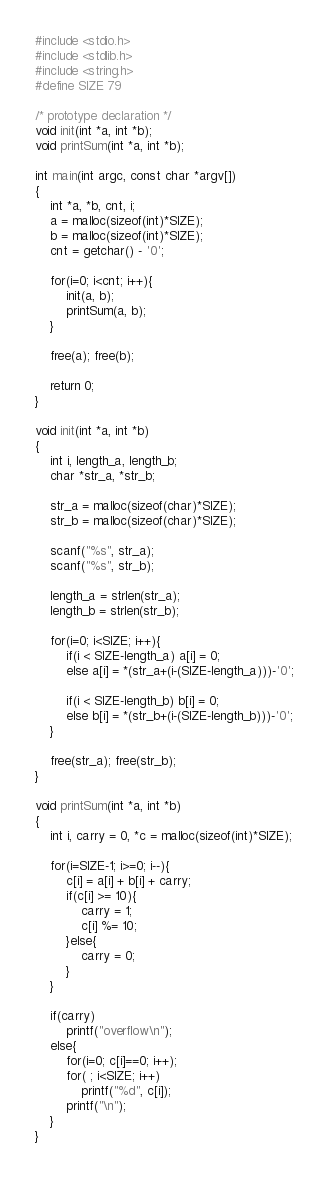<code> <loc_0><loc_0><loc_500><loc_500><_C_>#include <stdio.h>
#include <stdlib.h>
#include <string.h>
#define SIZE 79 

/* prototype declaration */
void init(int *a, int *b);
void printSum(int *a, int *b);

int main(int argc, const char *argv[])
{
	int *a, *b, cnt, i;
	a = malloc(sizeof(int)*SIZE);
	b = malloc(sizeof(int)*SIZE);
	cnt = getchar() - '0';

	for(i=0; i<cnt; i++){
		init(a, b);
		printSum(a, b);
	}
	
	free(a); free(b);

	return 0;
}

void init(int *a, int *b)
{
	int i, length_a, length_b;
	char *str_a, *str_b;

	str_a = malloc(sizeof(char)*SIZE);
	str_b = malloc(sizeof(char)*SIZE);

	scanf("%s", str_a);
	scanf("%s", str_b);

	length_a = strlen(str_a);
	length_b = strlen(str_b);

	for(i=0; i<SIZE; i++){
		if(i < SIZE-length_a) a[i] = 0;
		else a[i] = *(str_a+(i-(SIZE-length_a)))-'0';
		
		if(i < SIZE-length_b) b[i] = 0;
		else b[i] = *(str_b+(i-(SIZE-length_b)))-'0';
	}

	free(str_a); free(str_b);
}

void printSum(int *a, int *b)
{
	int i, carry = 0, *c = malloc(sizeof(int)*SIZE);
	
	for(i=SIZE-1; i>=0; i--){
		c[i] = a[i] + b[i] + carry;
		if(c[i] >= 10){
			carry = 1;
			c[i] %= 10;
		}else{
			carry = 0;
		}
	}

	if(carry)
		printf("overflow\n");
	else{
		for(i=0; c[i]==0; i++);
		for( ; i<SIZE; i++)
			printf("%d", c[i]);
		printf("\n");
	}	
}</code> 